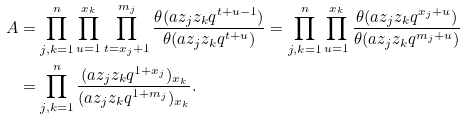<formula> <loc_0><loc_0><loc_500><loc_500>A & = \prod _ { j , k = 1 } ^ { n } \prod _ { u = 1 } ^ { x _ { k } } \prod _ { t = x _ { j } + 1 } ^ { m _ { j } } \frac { \theta ( a z _ { j } z _ { k } q ^ { t + u - 1 } ) } { \theta ( a z _ { j } z _ { k } q ^ { t + u } ) } = \prod _ { j , k = 1 } ^ { n } \prod _ { u = 1 } ^ { x _ { k } } \frac { \theta ( a z _ { j } z _ { k } q ^ { x _ { j } + u } ) } { \theta ( a z _ { j } z _ { k } q ^ { m _ { j } + u } ) } \\ & = \prod _ { j , k = 1 } ^ { n } \frac { ( a z _ { j } z _ { k } q ^ { 1 + x _ { j } } ) _ { x _ { k } } } { ( a z _ { j } z _ { k } q ^ { 1 + m _ { j } } ) _ { x _ { k } } } .</formula> 